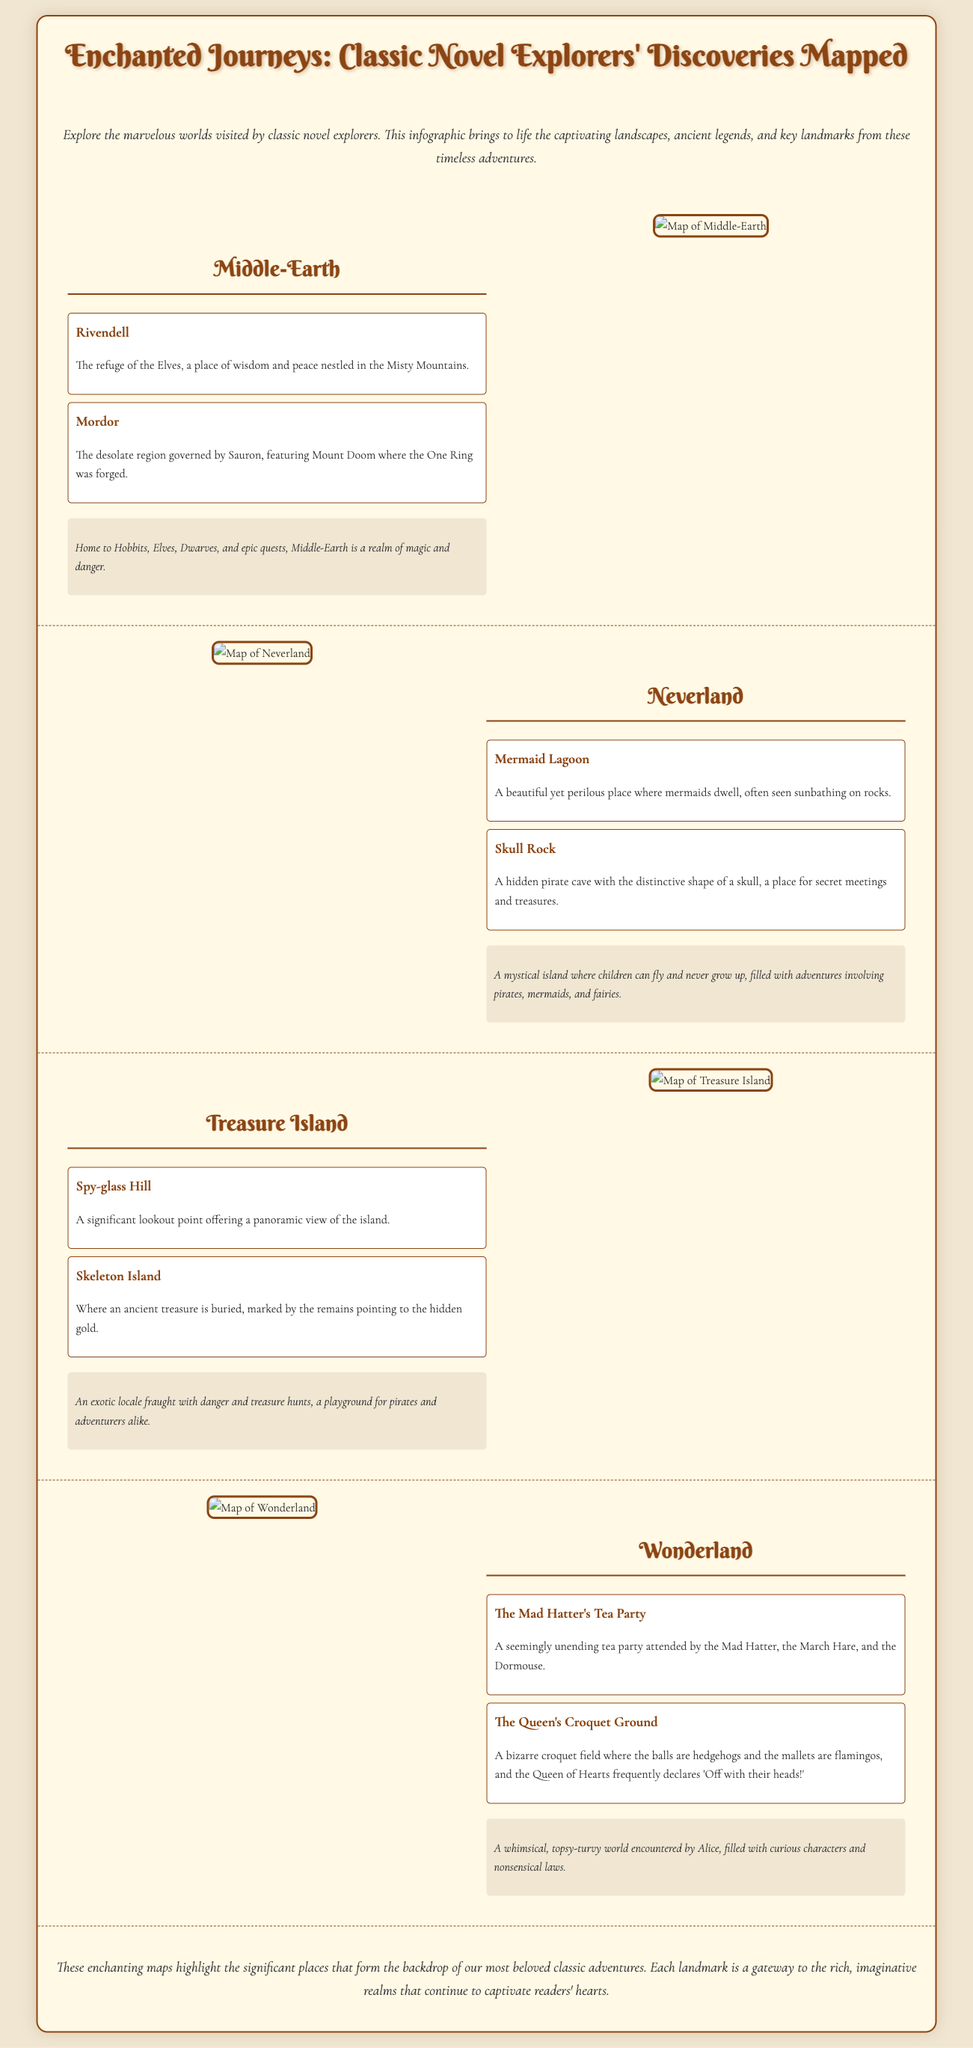what is the title of the infographic? The title is clearly stated at the top of the document, showcasing the focus on classic novel explorations.
Answer: Enchanted Journeys: Classic Novel Explorers' Discoveries Mapped how many significant locations are mentioned for Middle-Earth? The document lists two key landmarks under Middle-Earth, which are specified in the section.
Answer: 2 what is the name of the lagoon featured in Neverland? The specific landmark mentioned in the document is highlighted in the Neverland section.
Answer: Mermaid Lagoon which character’s tea party is included in Wonderland? The tea party is described prominently in the landmarks related to Wonderland in the document.
Answer: The Mad Hatter what is the first mentioned landmark in Treasure Island? The first landmark listed under Treasure Island provides a key location on the map.
Answer: Spy-glass Hill what significant feature distinguishes the Queen's Croquet Ground? The description provided indicates a unique characteristic of the croquet ground related to the gameplay.
Answer: Hedgehogs and flamingos which infamous figure rules over Mordor? The document specifically identifies Sauron as the ruling figure in the description of Mordor.
Answer: Sauron how is Neverland defined in the legend? The legend summarizes the essence of Neverland as described in the infographic.
Answer: A mystical island where children can fly and never grow up 